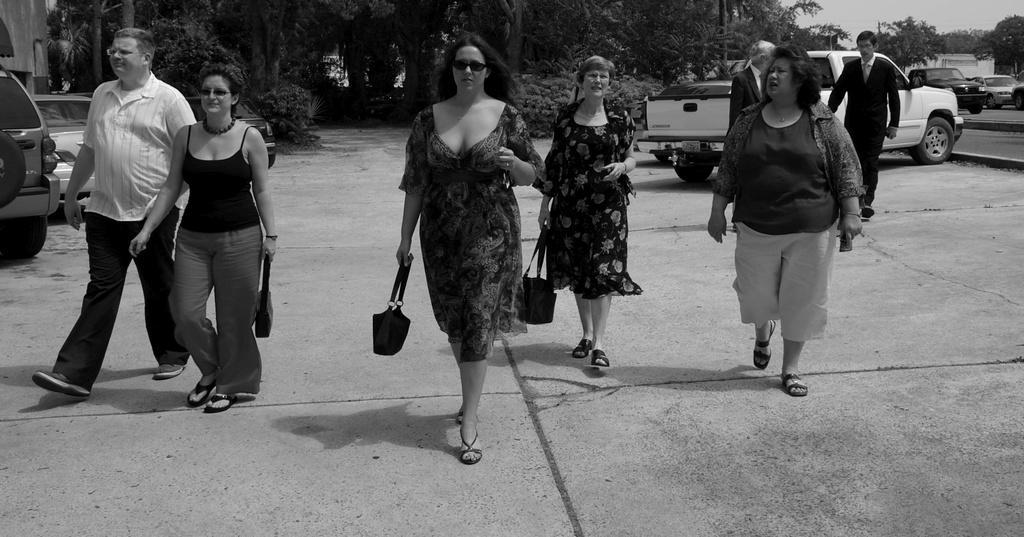Can you describe this image briefly? This is a black and white image. People are walking holding bags. There are vehicles and trees behind them. There are 2 people at the right back wearing suit. There are vehicles on the road on the right side. 